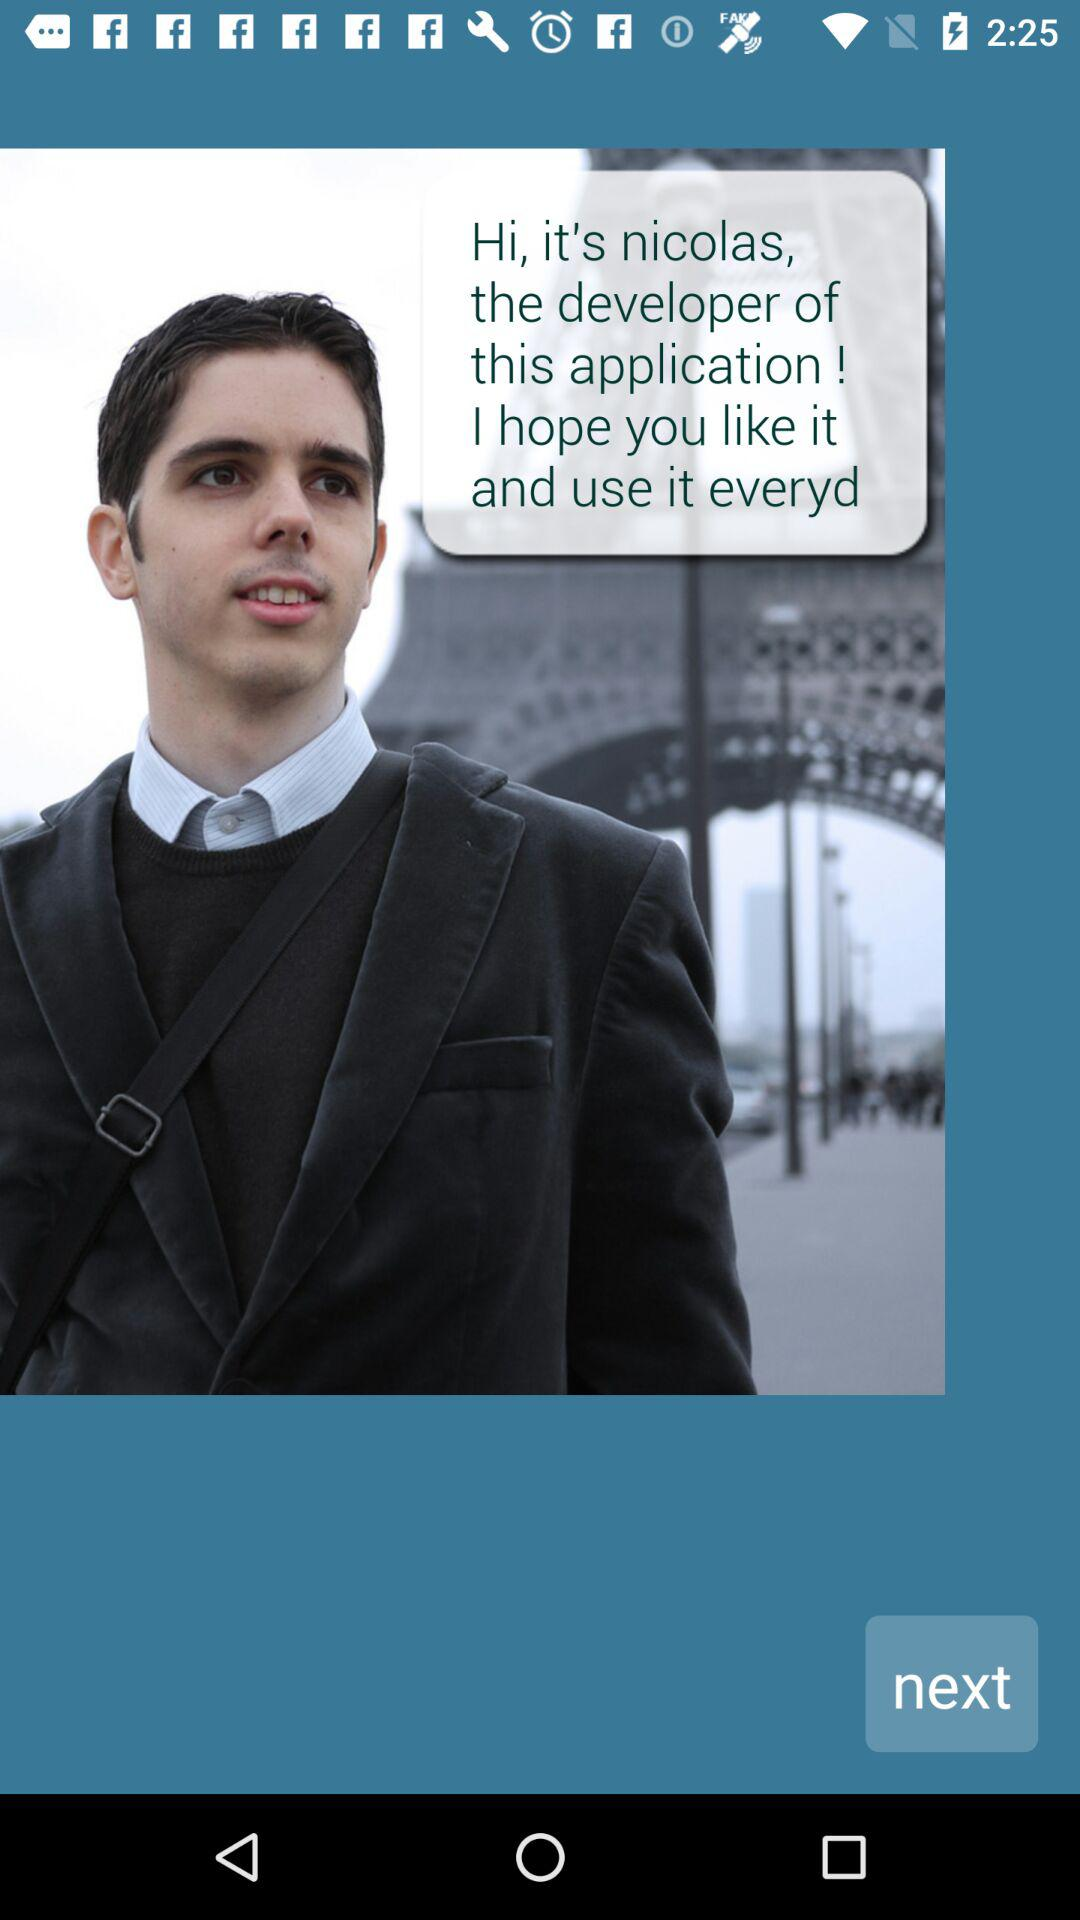Who is the developer of the application? The developer of the application is Nicolas. 